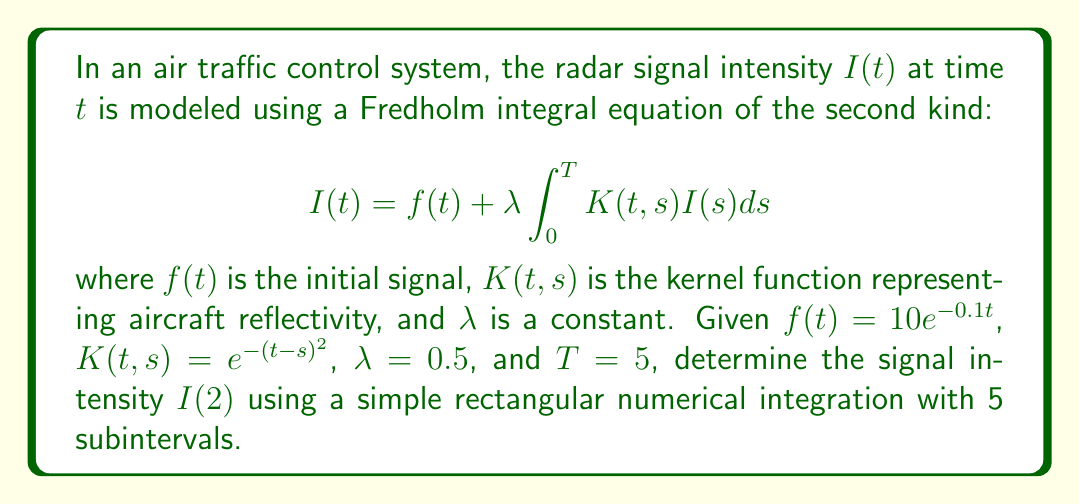Can you solve this math problem? To solve this problem, we'll use the rectangular numerical integration method to approximate the integral in the Fredholm equation. Here's the step-by-step process:

1) We need to calculate $I(2)$, so we'll focus on the equation when $t = 2$:

   $$I(2) = f(2) + 0.5 \int_0^5 e^{-(2-s)^2}I(s)ds$$

2) Calculate $f(2)$:
   $$f(2) = 10e^{-0.1(2)} = 10e^{-0.2} \approx 8.1873$$

3) For the integral, we'll divide the interval [0, 5] into 5 subintervals, each with width $\Delta s = 1$. The midpoints of these subintervals are 0.5, 1.5, 2.5, 3.5, and 4.5.

4) The rectangular approximation of the integral is:

   $$\int_0^5 e^{-(2-s)^2}I(s)ds \approx \sum_{i=1}^5 e^{-(2-s_i)^2}I(s_i) \cdot \Delta s$$

   where $s_i$ are the midpoints of the subintervals.

5) We don't know the exact values of $I(s_i)$, so we'll use the original equation to approximate them:

   $$I(s_i) \approx f(s_i) = 10e^{-0.1s_i}$$

6) Now we can calculate the sum:

   $$\sum_{i=1}^5 e^{-(2-s_i)^2} \cdot 10e^{-0.1s_i} \cdot 1$$

   $= e^{-(2-0.5)^2} \cdot 10e^{-0.1(0.5)} + e^{-(2-1.5)^2} \cdot 10e^{-0.1(1.5)} + e^{-(2-2.5)^2} \cdot 10e^{-0.1(2.5)} + e^{-(2-3.5)^2} \cdot 10e^{-0.1(3.5)} + e^{-(2-4.5)^2} \cdot 10e^{-0.1(4.5)}$

   $\approx 2.6995 + 8.1811 + 7.7880 + 2.3404 + 0.2231 = 21.2321$

7) Putting it all together:

   $$I(2) \approx 8.1873 + 0.5 \cdot 21.2321 = 18.8034$$
Answer: $18.8034$ 